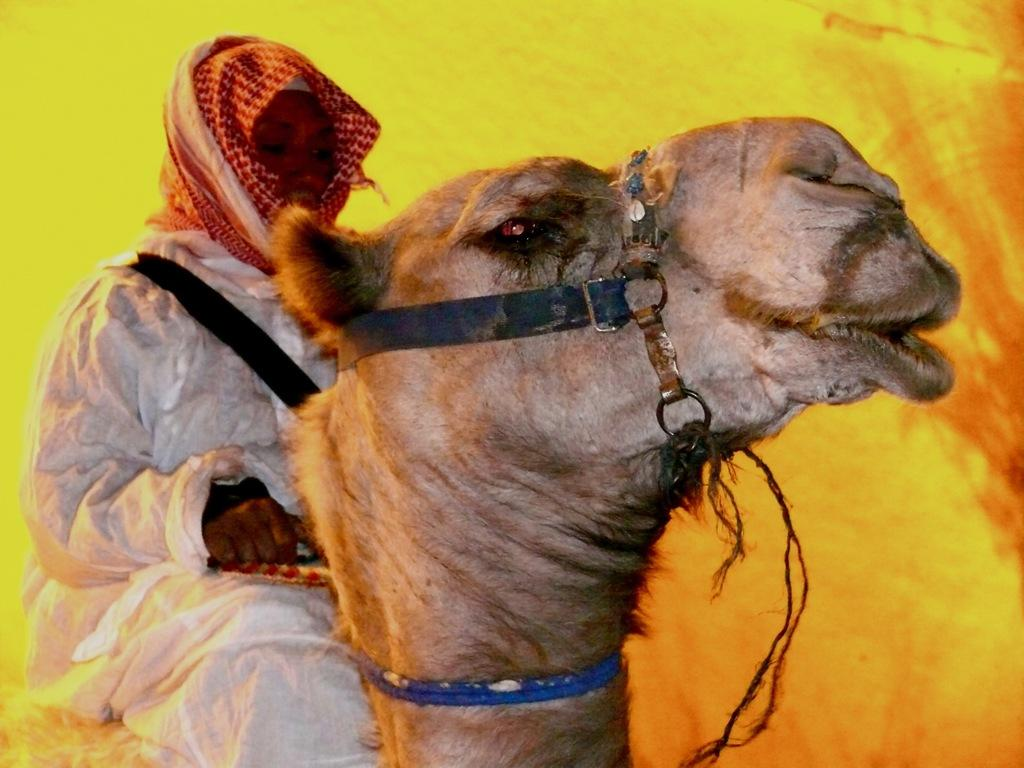What is the person in the image doing? The person is sitting on a camel in the image. What can be observed about the background of the image? The background of the image is yellow. How many cherries can be seen on the camel's back in the image? There are no cherries present in the image, as it features a person sitting on a camel with a yellow background. 